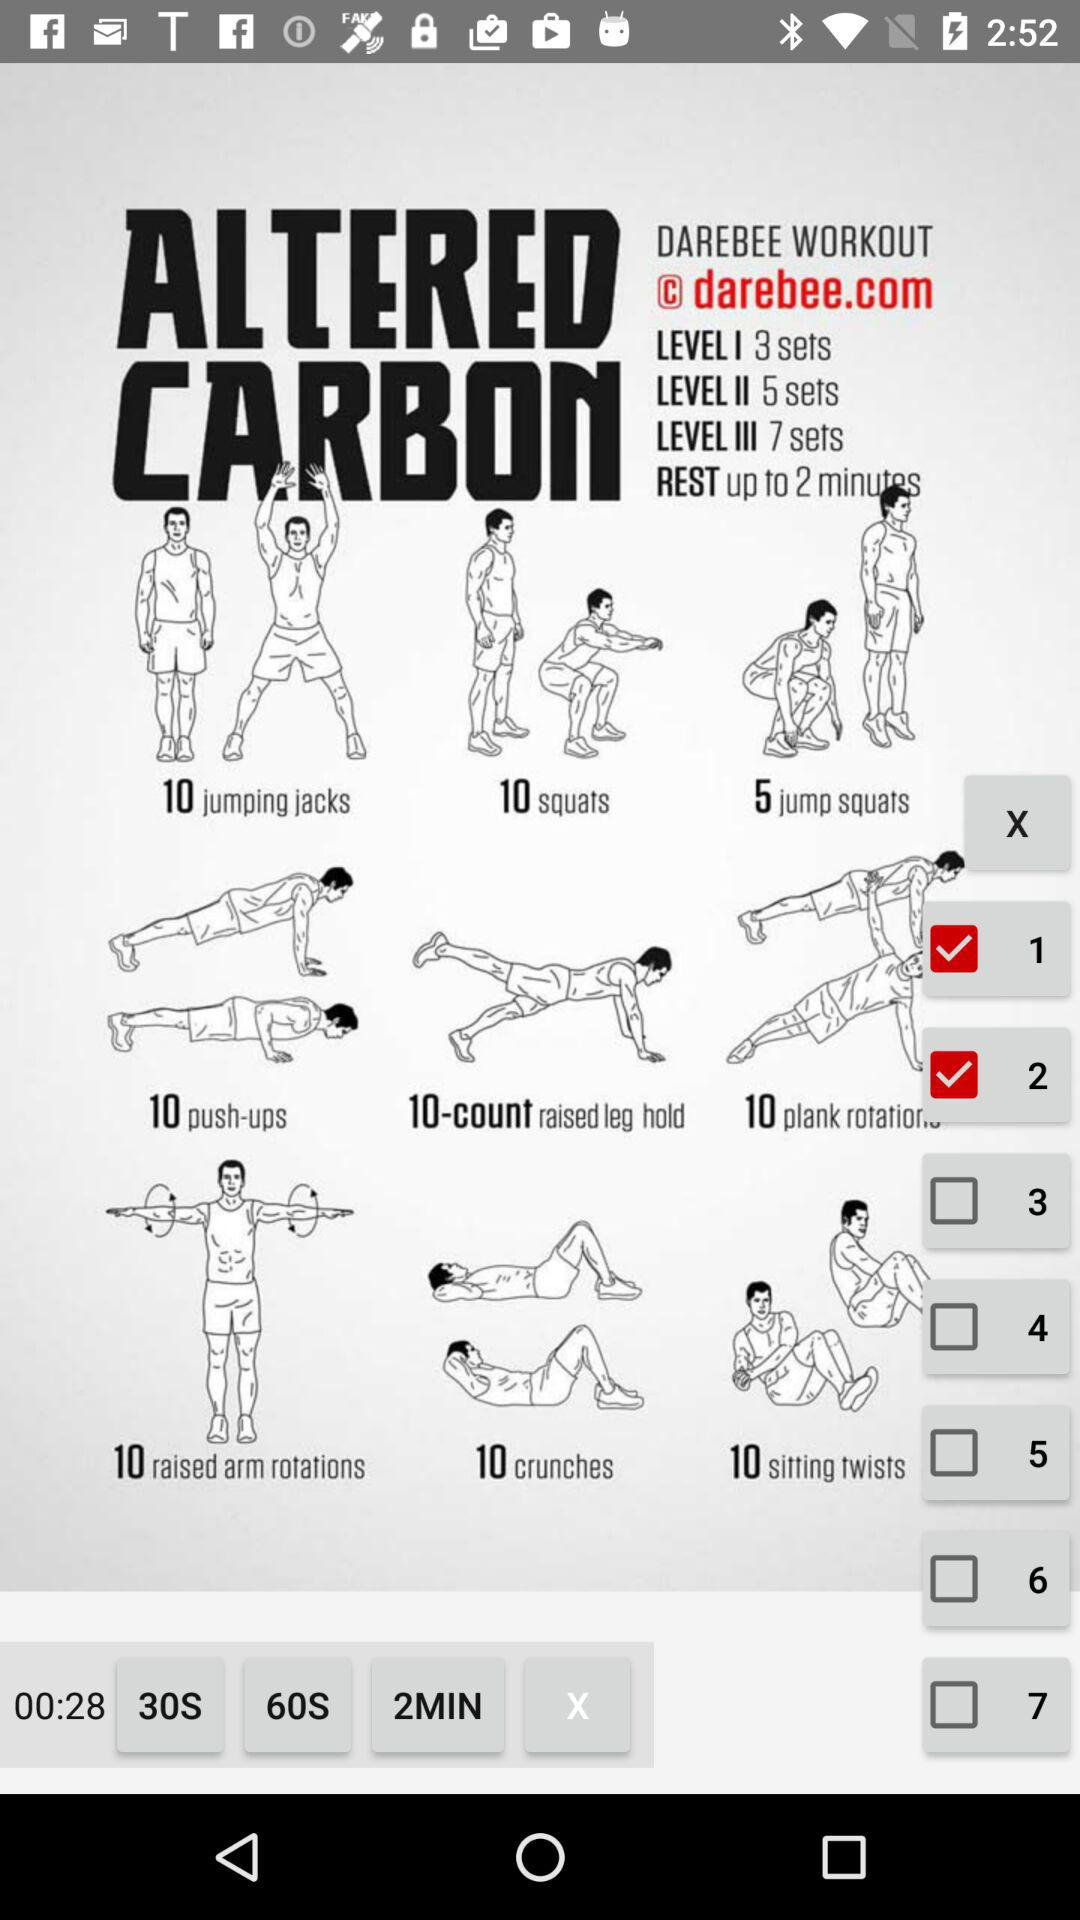What is the number of sets in level 2? There are 5 sets in level 2. 